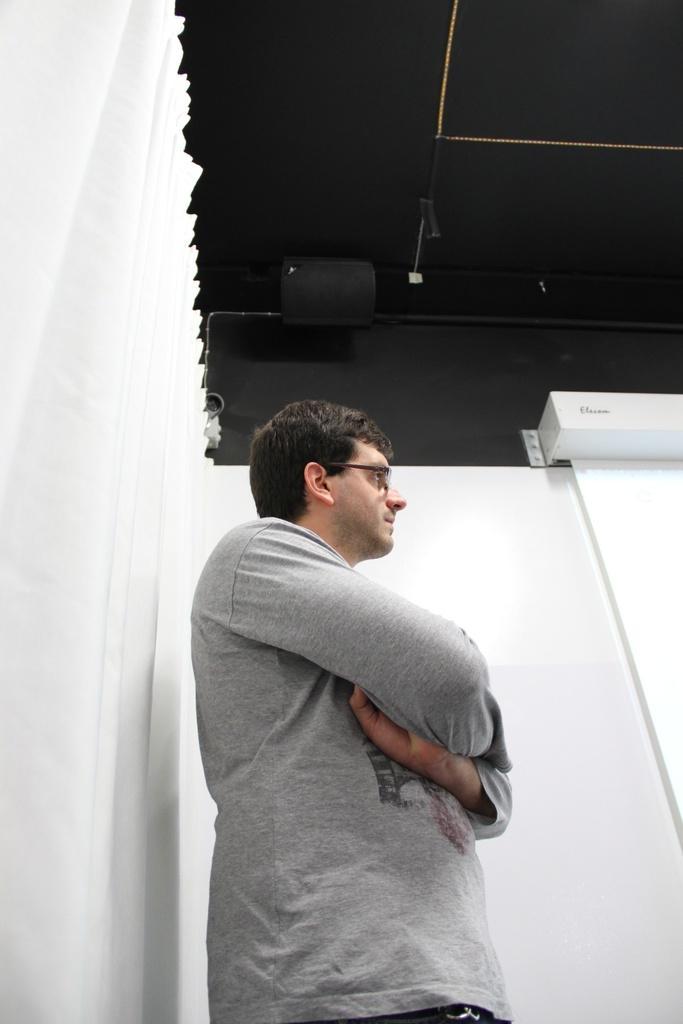Could you give a brief overview of what you see in this image? In the middle of the image a man is standing. Beside him there is wall. At the top of the image there is ceiling. 